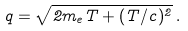<formula> <loc_0><loc_0><loc_500><loc_500>q = \sqrt { 2 m _ { e } T + ( T / c ) ^ { 2 } } \, .</formula> 